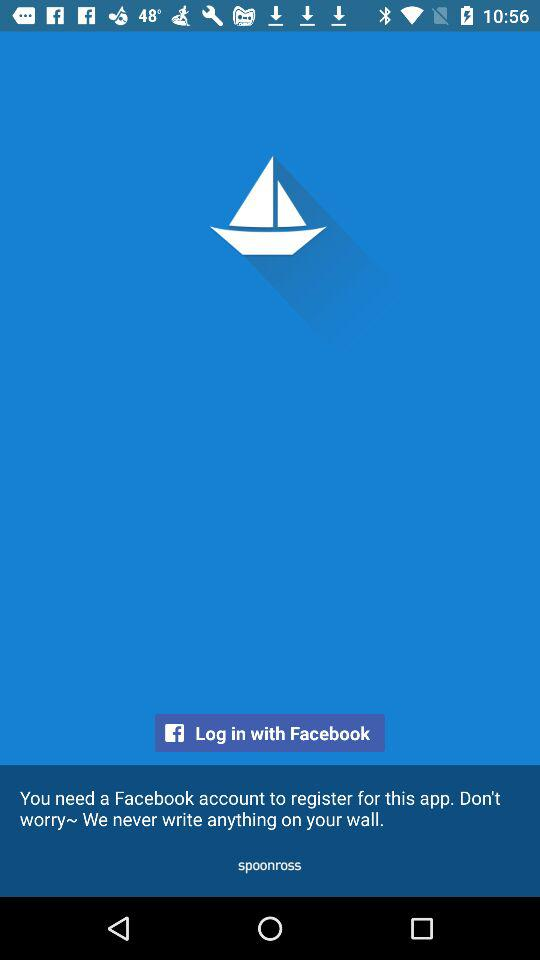Through which application can the user log in? The application is "Facebook". 